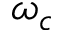<formula> <loc_0><loc_0><loc_500><loc_500>\omega _ { c }</formula> 